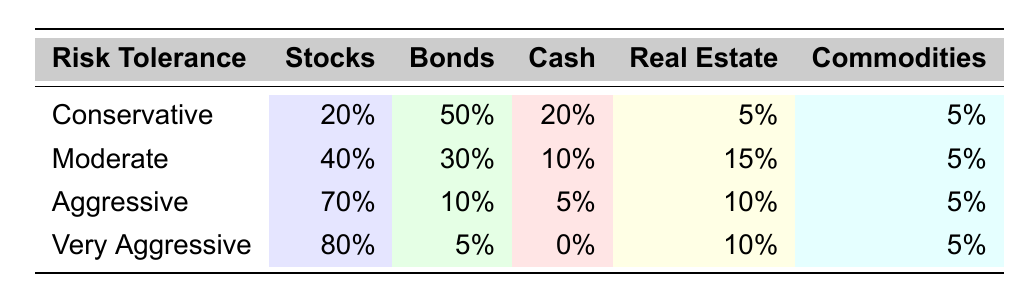What percentage of the Conservative allocation is in Bonds? The Conservative strategy has 50% in Bonds as shown directly in the table under the Conservative row.
Answer: 50% What is the total percentage allocated to Cash in an Aggressive portfolio? The Aggressive strategy includes 5% in Cash as per the data in the table.
Answer: 5% Which risk tolerance has the highest percentage allocated to Real Estate? The Very Aggressive portfolio has 10% allocated to Real Estate, which is the highest compared to all other risk tolerances stated in the table.
Answer: Very Aggressive Is it true that the Moderate portfolio has more Bonds than the Aggressive portfolio? Yes, the Moderate portfolio allocates 30% to Bonds, while the Aggressive portfolio only allocates 10%, confirming the statement is true.
Answer: Yes What is the average percentage allocated to Commodities across all risk tolerances? The percentages for Commodities are 5%, 5%, 5%, and 5% across Conservative, Moderate, Aggressive, and Very Aggressive respectively. Summing these (5 + 5 + 5 + 5 = 20) and dividing by 4 gives an average of 20/4 = 5%.
Answer: 5% How much more is allocated to Stocks in a Very Aggressive portfolio compared to a Conservative portfolio? The Very Aggressive portfolio allocates 80% to Stocks, while the Conservative portfolio allocates 20%. The difference is calculated by subtracting 20 from 80: 80 - 20 = 60%.
Answer: 60% If you were to combine the Bonds and Cash allocations for a Moderate portfolio, what would the total be? The Moderate portfolio allocates 30% to Bonds and 10% to Cash. Adding these values gives: 30 + 10 = 40%.
Answer: 40% Which risk tolerance has the least allocation to Cash? The Very Aggressive portfolio allocates 0% to Cash, which is less than any other risk tolerance in the provided data.
Answer: Very Aggressive How does the total percentage in Stocks for Conservative compare to that of Aggressive? Conservative has 20% in Stocks and Aggressive has 70%. The difference is calculated as: 70 - 20 = 50%, meaning Aggressive has 50% more in Stocks than Conservative.
Answer: Aggressive has 50% more 